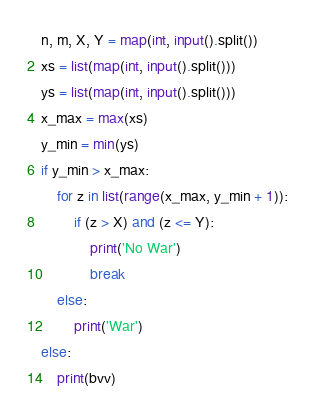<code> <loc_0><loc_0><loc_500><loc_500><_Python_>n, m, X, Y = map(int, input().split())
xs = list(map(int, input().split()))
ys = list(map(int, input().split()))
x_max = max(xs)
y_min = min(ys)
if y_min > x_max:
    for z in list(range(x_max, y_min + 1)):
        if (z > X) and (z <= Y):
            print('No War')
            break
    else:
        print('War')
else:
    print(bvv)</code> 